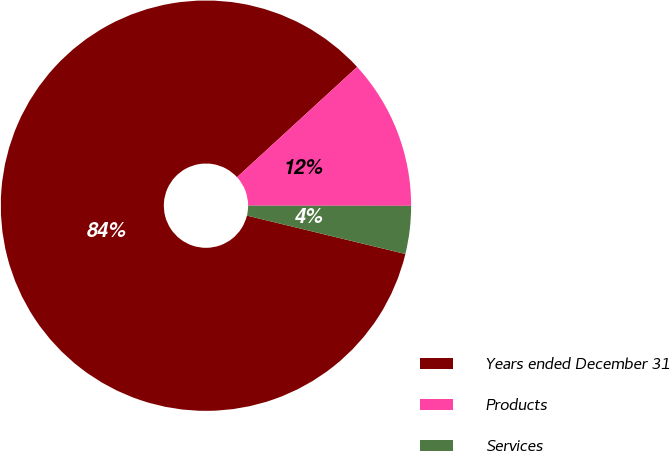<chart> <loc_0><loc_0><loc_500><loc_500><pie_chart><fcel>Years ended December 31<fcel>Products<fcel>Services<nl><fcel>84.4%<fcel>11.83%<fcel>3.77%<nl></chart> 